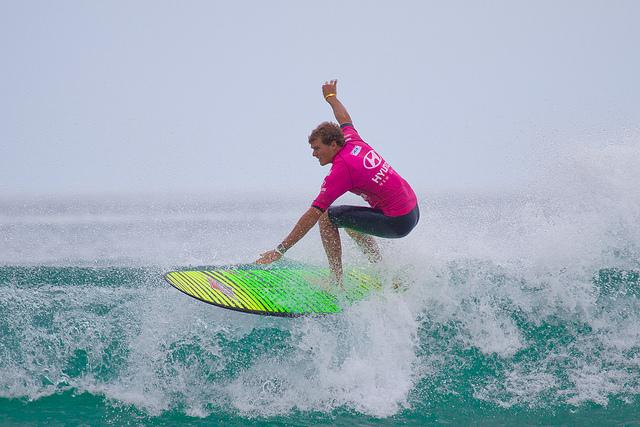What color are the man's shorts?
Give a very brief answer. Black. What is the man standing on?
Short answer required. Surfboard. What car company  is on the back of the man's shirt?
Keep it brief. Hyundai. 